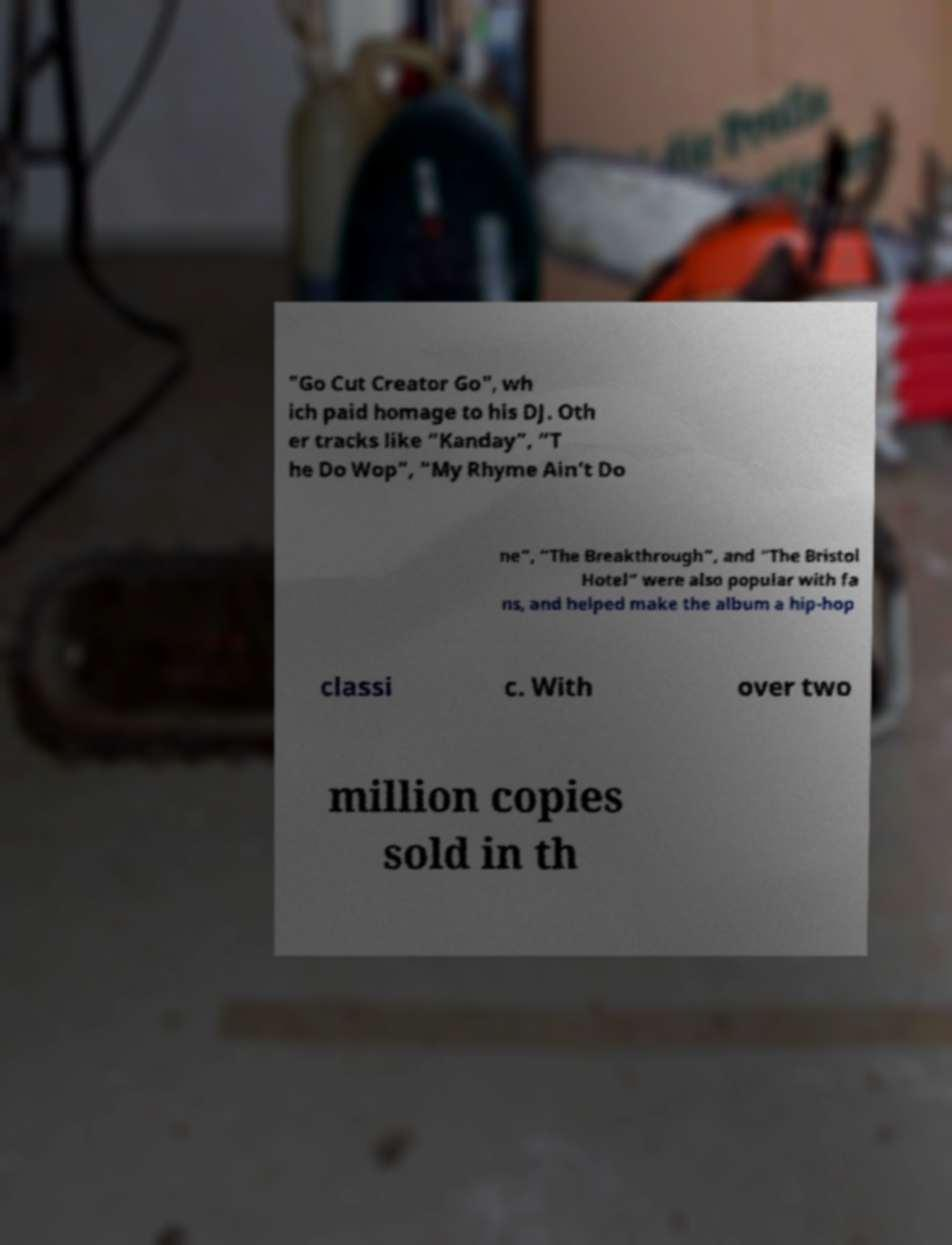Please identify and transcribe the text found in this image. "Go Cut Creator Go", wh ich paid homage to his DJ. Oth er tracks like “Kanday”, “T he Do Wop”, “My Rhyme Ain’t Do ne”, “The Breakthrough”, and “The Bristol Hotel” were also popular with fa ns, and helped make the album a hip-hop classi c. With over two million copies sold in th 